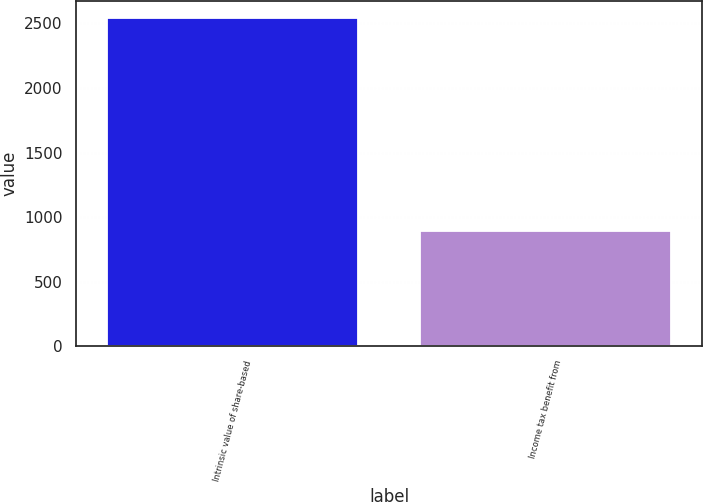Convert chart to OTSL. <chart><loc_0><loc_0><loc_500><loc_500><bar_chart><fcel>Intrinsic value of share-based<fcel>Income tax benefit from<nl><fcel>2546<fcel>891<nl></chart> 